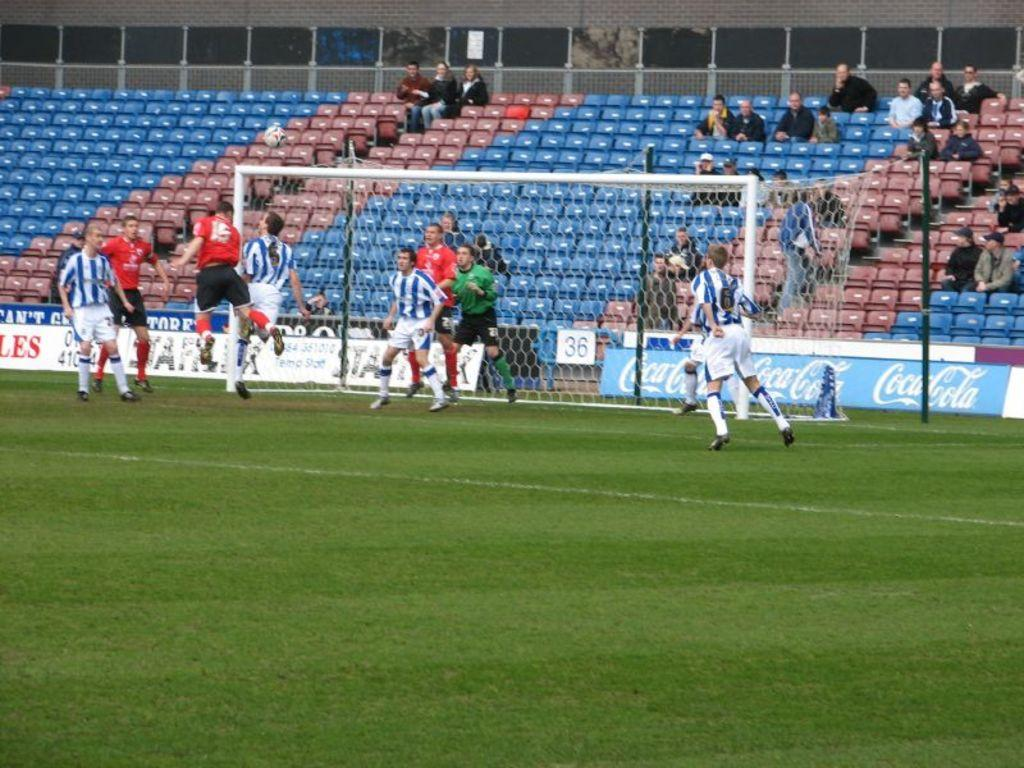Provide a one-sentence caption for the provided image. group of men playing soccer and a few people watching. 